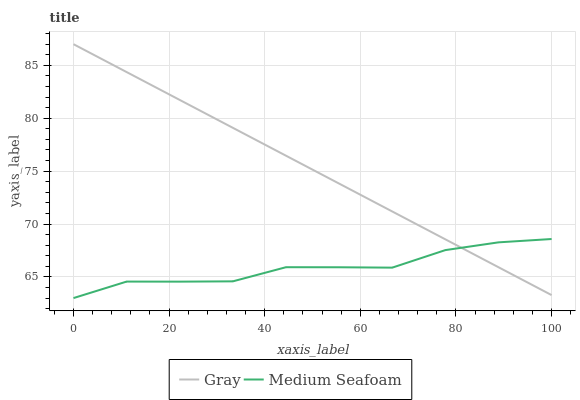Does Medium Seafoam have the minimum area under the curve?
Answer yes or no. Yes. Does Gray have the maximum area under the curve?
Answer yes or no. Yes. Does Medium Seafoam have the maximum area under the curve?
Answer yes or no. No. Is Gray the smoothest?
Answer yes or no. Yes. Is Medium Seafoam the roughest?
Answer yes or no. Yes. Is Medium Seafoam the smoothest?
Answer yes or no. No. Does Gray have the highest value?
Answer yes or no. Yes. Does Medium Seafoam have the highest value?
Answer yes or no. No. Does Gray intersect Medium Seafoam?
Answer yes or no. Yes. Is Gray less than Medium Seafoam?
Answer yes or no. No. Is Gray greater than Medium Seafoam?
Answer yes or no. No. 